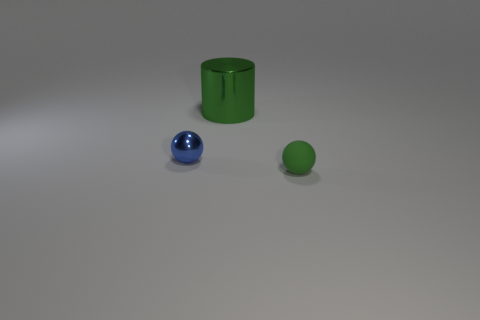How many objects are spheres behind the green matte sphere or tiny things that are right of the small blue metallic ball?
Offer a very short reply. 2. Are the small blue thing and the thing right of the metal cylinder made of the same material?
Provide a succinct answer. No. There is a thing that is left of the green ball and in front of the big metal cylinder; what is its shape?
Provide a succinct answer. Sphere. How many other objects are there of the same color as the tiny rubber ball?
Your answer should be compact. 1. The green metal object is what shape?
Offer a terse response. Cylinder. There is a small sphere that is in front of the tiny ball left of the green ball; what is its color?
Provide a succinct answer. Green. Does the big object have the same color as the tiny object on the left side of the rubber sphere?
Your answer should be compact. No. What is the thing that is both right of the metal ball and on the left side of the matte ball made of?
Your answer should be compact. Metal. Is there a purple shiny cube that has the same size as the green matte thing?
Make the answer very short. No. There is a object that is the same size as the green rubber ball; what is it made of?
Your answer should be compact. Metal. 